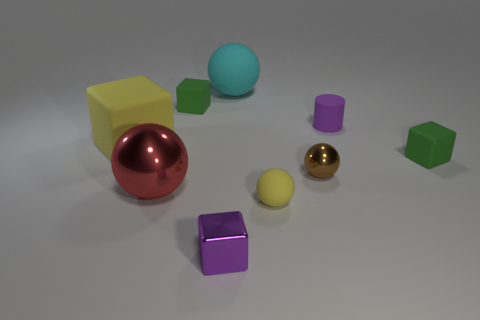Add 1 big metallic balls. How many objects exist? 10 Subtract all cylinders. How many objects are left? 8 Subtract 0 blue balls. How many objects are left? 9 Subtract all small red rubber cylinders. Subtract all green things. How many objects are left? 7 Add 1 small brown metallic spheres. How many small brown metallic spheres are left? 2 Add 4 cubes. How many cubes exist? 8 